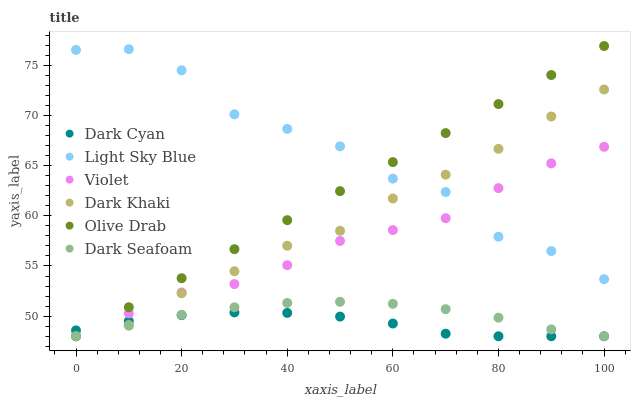Does Dark Cyan have the minimum area under the curve?
Answer yes or no. Yes. Does Light Sky Blue have the maximum area under the curve?
Answer yes or no. Yes. Does Dark Seafoam have the minimum area under the curve?
Answer yes or no. No. Does Dark Seafoam have the maximum area under the curve?
Answer yes or no. No. Is Olive Drab the smoothest?
Answer yes or no. Yes. Is Light Sky Blue the roughest?
Answer yes or no. Yes. Is Dark Seafoam the smoothest?
Answer yes or no. No. Is Dark Seafoam the roughest?
Answer yes or no. No. Does Dark Khaki have the lowest value?
Answer yes or no. Yes. Does Light Sky Blue have the lowest value?
Answer yes or no. No. Does Olive Drab have the highest value?
Answer yes or no. Yes. Does Dark Seafoam have the highest value?
Answer yes or no. No. Is Dark Cyan less than Light Sky Blue?
Answer yes or no. Yes. Is Light Sky Blue greater than Dark Seafoam?
Answer yes or no. Yes. Does Light Sky Blue intersect Violet?
Answer yes or no. Yes. Is Light Sky Blue less than Violet?
Answer yes or no. No. Is Light Sky Blue greater than Violet?
Answer yes or no. No. Does Dark Cyan intersect Light Sky Blue?
Answer yes or no. No. 